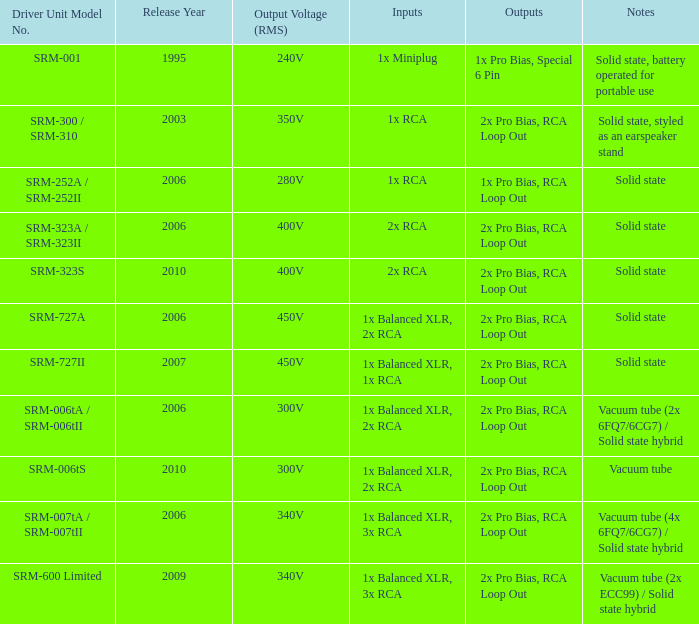What year were outputs is 2x pro bias, rca loop out and notes is vacuum tube released? 2010.0. 